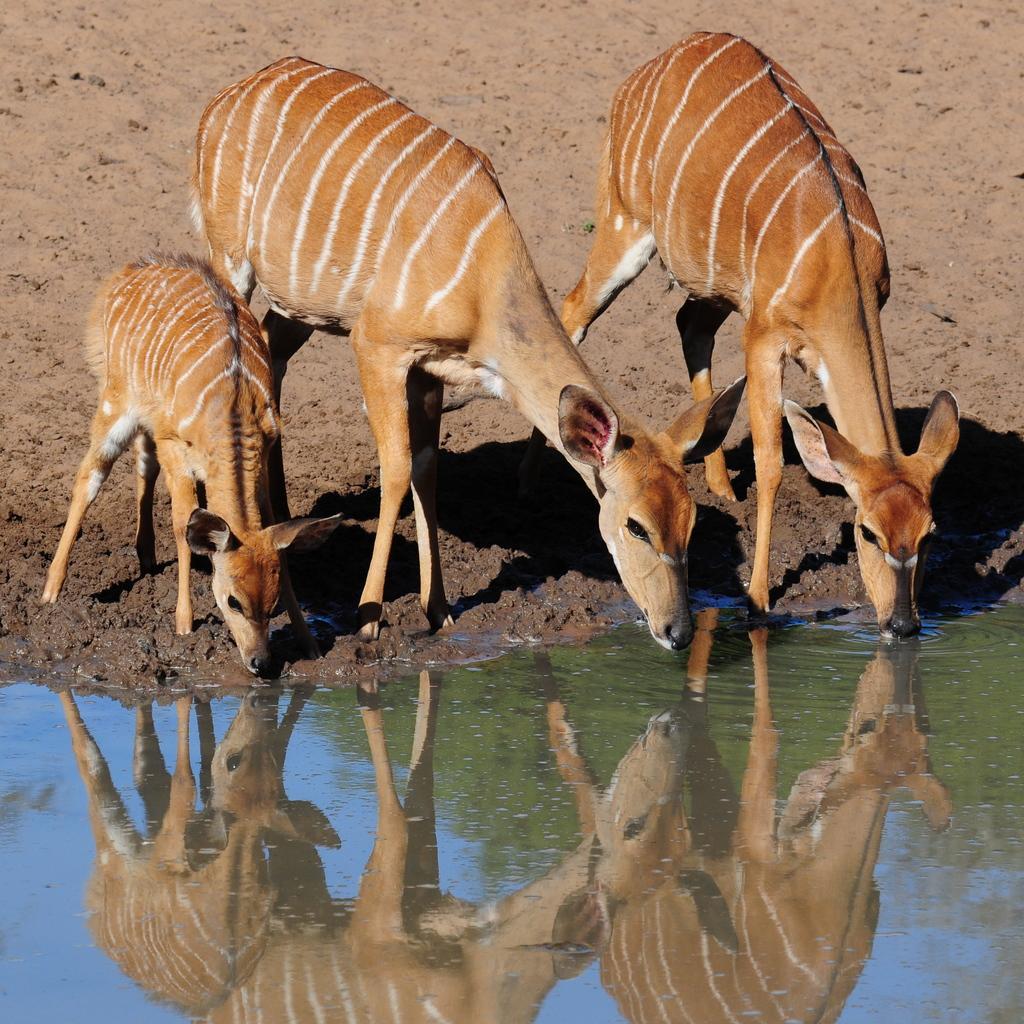How would you summarize this image in a sentence or two? In this picture I can see the animals on the surface. 